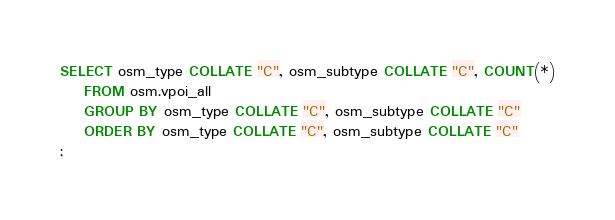<code> <loc_0><loc_0><loc_500><loc_500><_SQL_>SELECT osm_type COLLATE "C", osm_subtype COLLATE "C", COUNT(*)
    FROM osm.vpoi_all
    GROUP BY osm_type COLLATE "C", osm_subtype COLLATE "C"
    ORDER BY osm_type COLLATE "C", osm_subtype COLLATE "C"
;</code> 